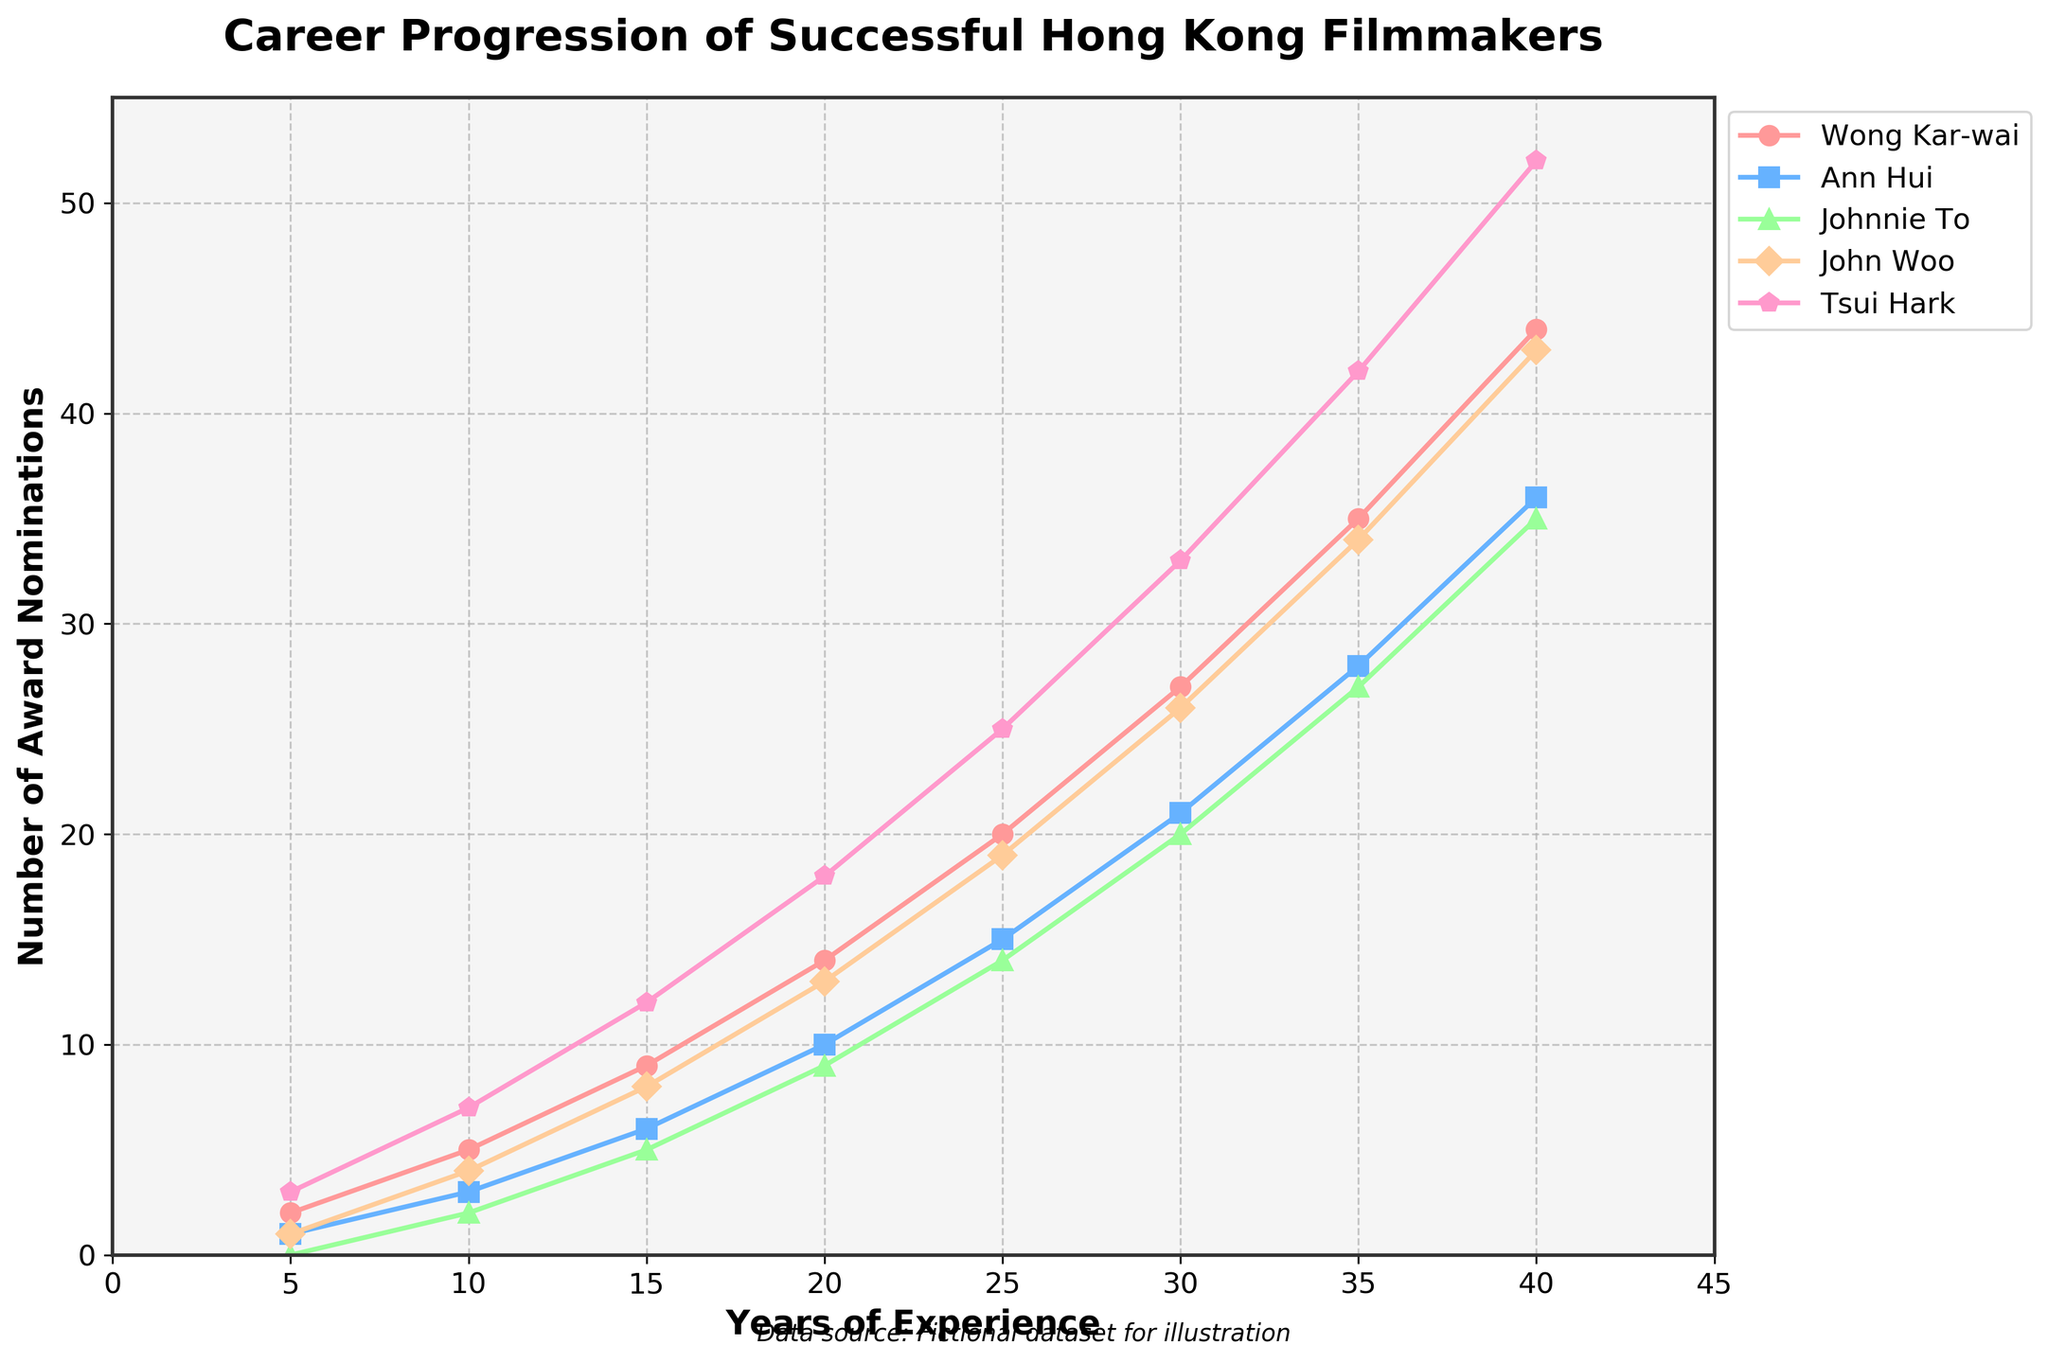Which filmmaker has the most award nominations after 30 years of experience? Look at the data points corresponding to 30 years of experience for each filmmaker. Wong Kar-wai has 27 nominations, Ann Hui 21, Johnnie To 20, John Woo 26, and Tsui Hark 33. Thus, Tsui Hark has the most nominations.
Answer: Tsui Hark How many more award nominations does Wong Kar-wai have than Johnnie To after 40 years of experience? Look at the data points corresponding to 40 years of experience. Wong Kar-wai has 44 nominations, and Johnnie To has 35 nominations. Subtract 35 from 44 to find the difference.
Answer: 9 Which filmmaker has the steepest increase in award nominations between 5 and 15 years of experience? Calculate the increase in nominations for each filmmaker from 5 to 15 years: Wong Kar-wai (9-2=7), Ann Hui (6-1=5), Johnnie To (5-0=5), John Woo (8-1=7), Tsui Hark (12-3=9). Tsui Hark has the steepest increase with 9.
Answer: Tsui Hark On average, how many award nominations do the filmmakers have after 20 years of experience? Add the number of nominations for each filmmaker at 20 years and divide by the number of filmmakers: (14 + 10 + 9 + 13 + 18)/5 = 12.8
Answer: 12.8 Who has more award nominations: John Woo after 25 years or Tsui Hark after 10 years? John Woo has 19 nominations after 25 years, and Tsui Hark has 7 nominations after 10 years.
Answer: John Woo What is the total increase in award nominations for Ann Hui from her first 5 years to her last 40 years? Calculate the total increase by subtracting the initial number from the final number: 36 - 1 = 35
Answer: 35 Between which two consecutive time points does Johnnie To see the largest increase in nominations? Calculate the increase for each interval: 0 to 2 (10 years), 2 to 5 (5 years), 5 to 9 (5 years), 9 to 14 (5 years), 14 to 20 (10 years), 20 to 27 (7 years), 27 to 35 (8 years). The largest increase is from 20 years to 27 years with 7 nominations.
Answer: 20 to 27 years What is the difference in the number of nominations between Tsui Hark and Ann Hui after 35 years of experience? Subtract the number of nominations of Ann Hui from Tsui Hark: 42 - 28 = 14
Answer: 14 Which filmmaker's nominations line intersects with John Woo's line first as their careers progress? Look for where any filmmaker's line first crosses John Woo's line. Wong Kar-wai's line intersects with John Woo's line around 12 years, where both have roughly 6-7 nominations.
Answer: Wong Kar-wai How many total nominations do the filmmakers have after 40 years of experience? Sum the nominations for all filmmakers at the 40-year mark: 44 (Wong Kar-wai) + 36 (Ann Hui) + 35 (Johnnie To) + 43 (John Woo) + 52 (Tsui Hark) = 210
Answer: 210 